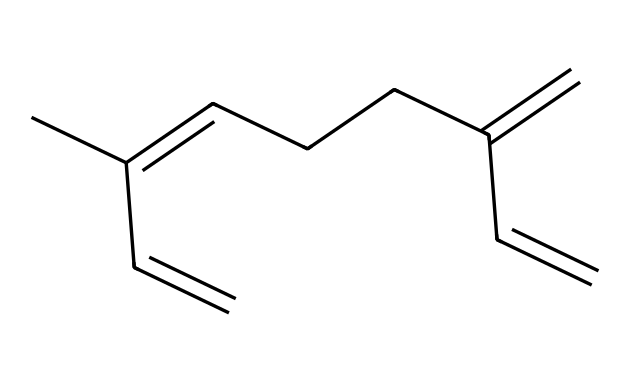How many carbon atoms are in myrcene? The SMILES representation indicates that there are a total of 10 carbon atoms present in the structure, as each "C" in the SMILES denotes a carbon atom.
Answer: 10 What is the highest degree of unsaturation in myrcene? The structure of myrcene shows a total of 3 double bonds (C=C), and each double bond contributes one degree of unsaturation. Thus, it has a maximum of 3 degrees of unsaturation.
Answer: 3 Is myrcene a cyclic or acyclic compound? The structure indicates that the carbon atoms are connected in a linear manner without forming a ring, thus it is acyclic.
Answer: acyclic What type of functional groups are present in myrcene? The SMILES shows that there are only double bonds (C=C) and no other distinct functional groups like alcohols, ketones, or carboxylic acids. Thus, it contains alkenes.
Answer: alkenes What is the primary use of myrcene? Myrcene is primarily utilized for its flavor and aroma properties, often found in essential oils and used in perfumes.
Answer: flavor and aroma How does the structure of myrcene affect its aromatic properties? The presence of multiple double bonds in myrcene contributes to its ability to engage in π-π interactions, enhancing its fragrant characteristics.
Answer: π-π interactions 